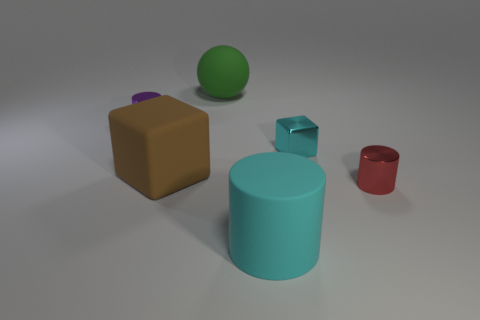Is there anything else that is made of the same material as the tiny purple cylinder?
Provide a succinct answer. Yes. Is the color of the rubber sphere the same as the big rubber object that is in front of the big brown cube?
Keep it short and to the point. No. What is the shape of the small purple shiny object?
Your response must be concise. Cylinder. How big is the cyan object that is behind the shiny cylinder right of the tiny metallic cylinder that is left of the small cyan metal cube?
Your response must be concise. Small. How many other objects are the same shape as the tiny purple thing?
Make the answer very short. 2. There is a large object that is in front of the tiny red metal thing; does it have the same shape as the metal object left of the big rubber ball?
Provide a succinct answer. Yes. How many blocks are large things or large yellow matte things?
Provide a short and direct response. 1. What is the block on the left side of the matte cylinder that is right of the tiny thing left of the large cyan rubber cylinder made of?
Provide a succinct answer. Rubber. What number of other objects are there of the same size as the green rubber ball?
Your response must be concise. 2. There is a thing that is the same color as the matte cylinder; what is its size?
Offer a very short reply. Small. 